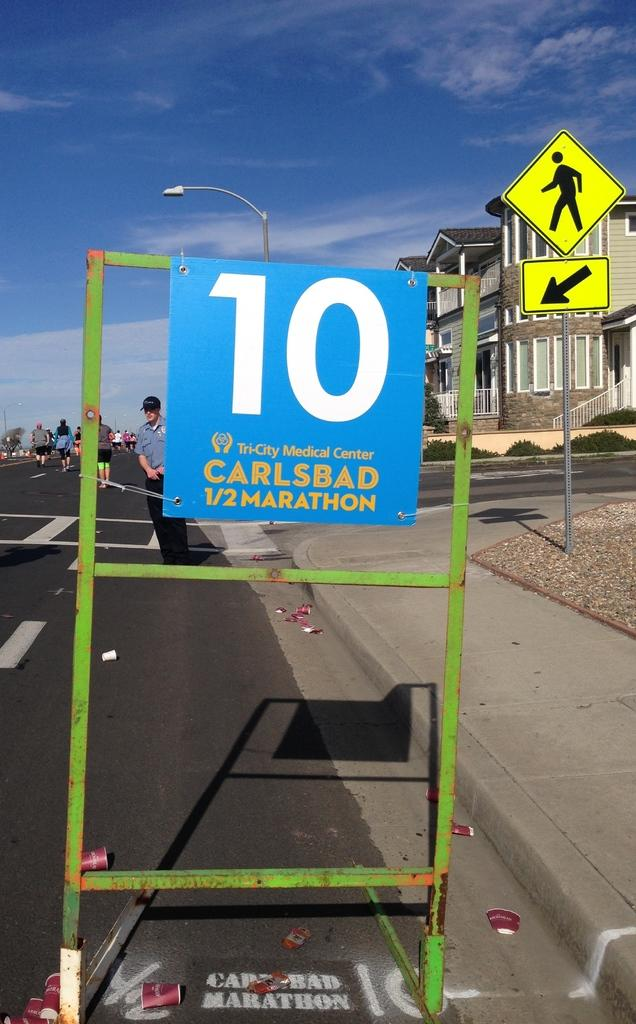<image>
Write a terse but informative summary of the picture. A blue sign for the Carlsbad 1/2 Marathon displays the number 10 in white text. 